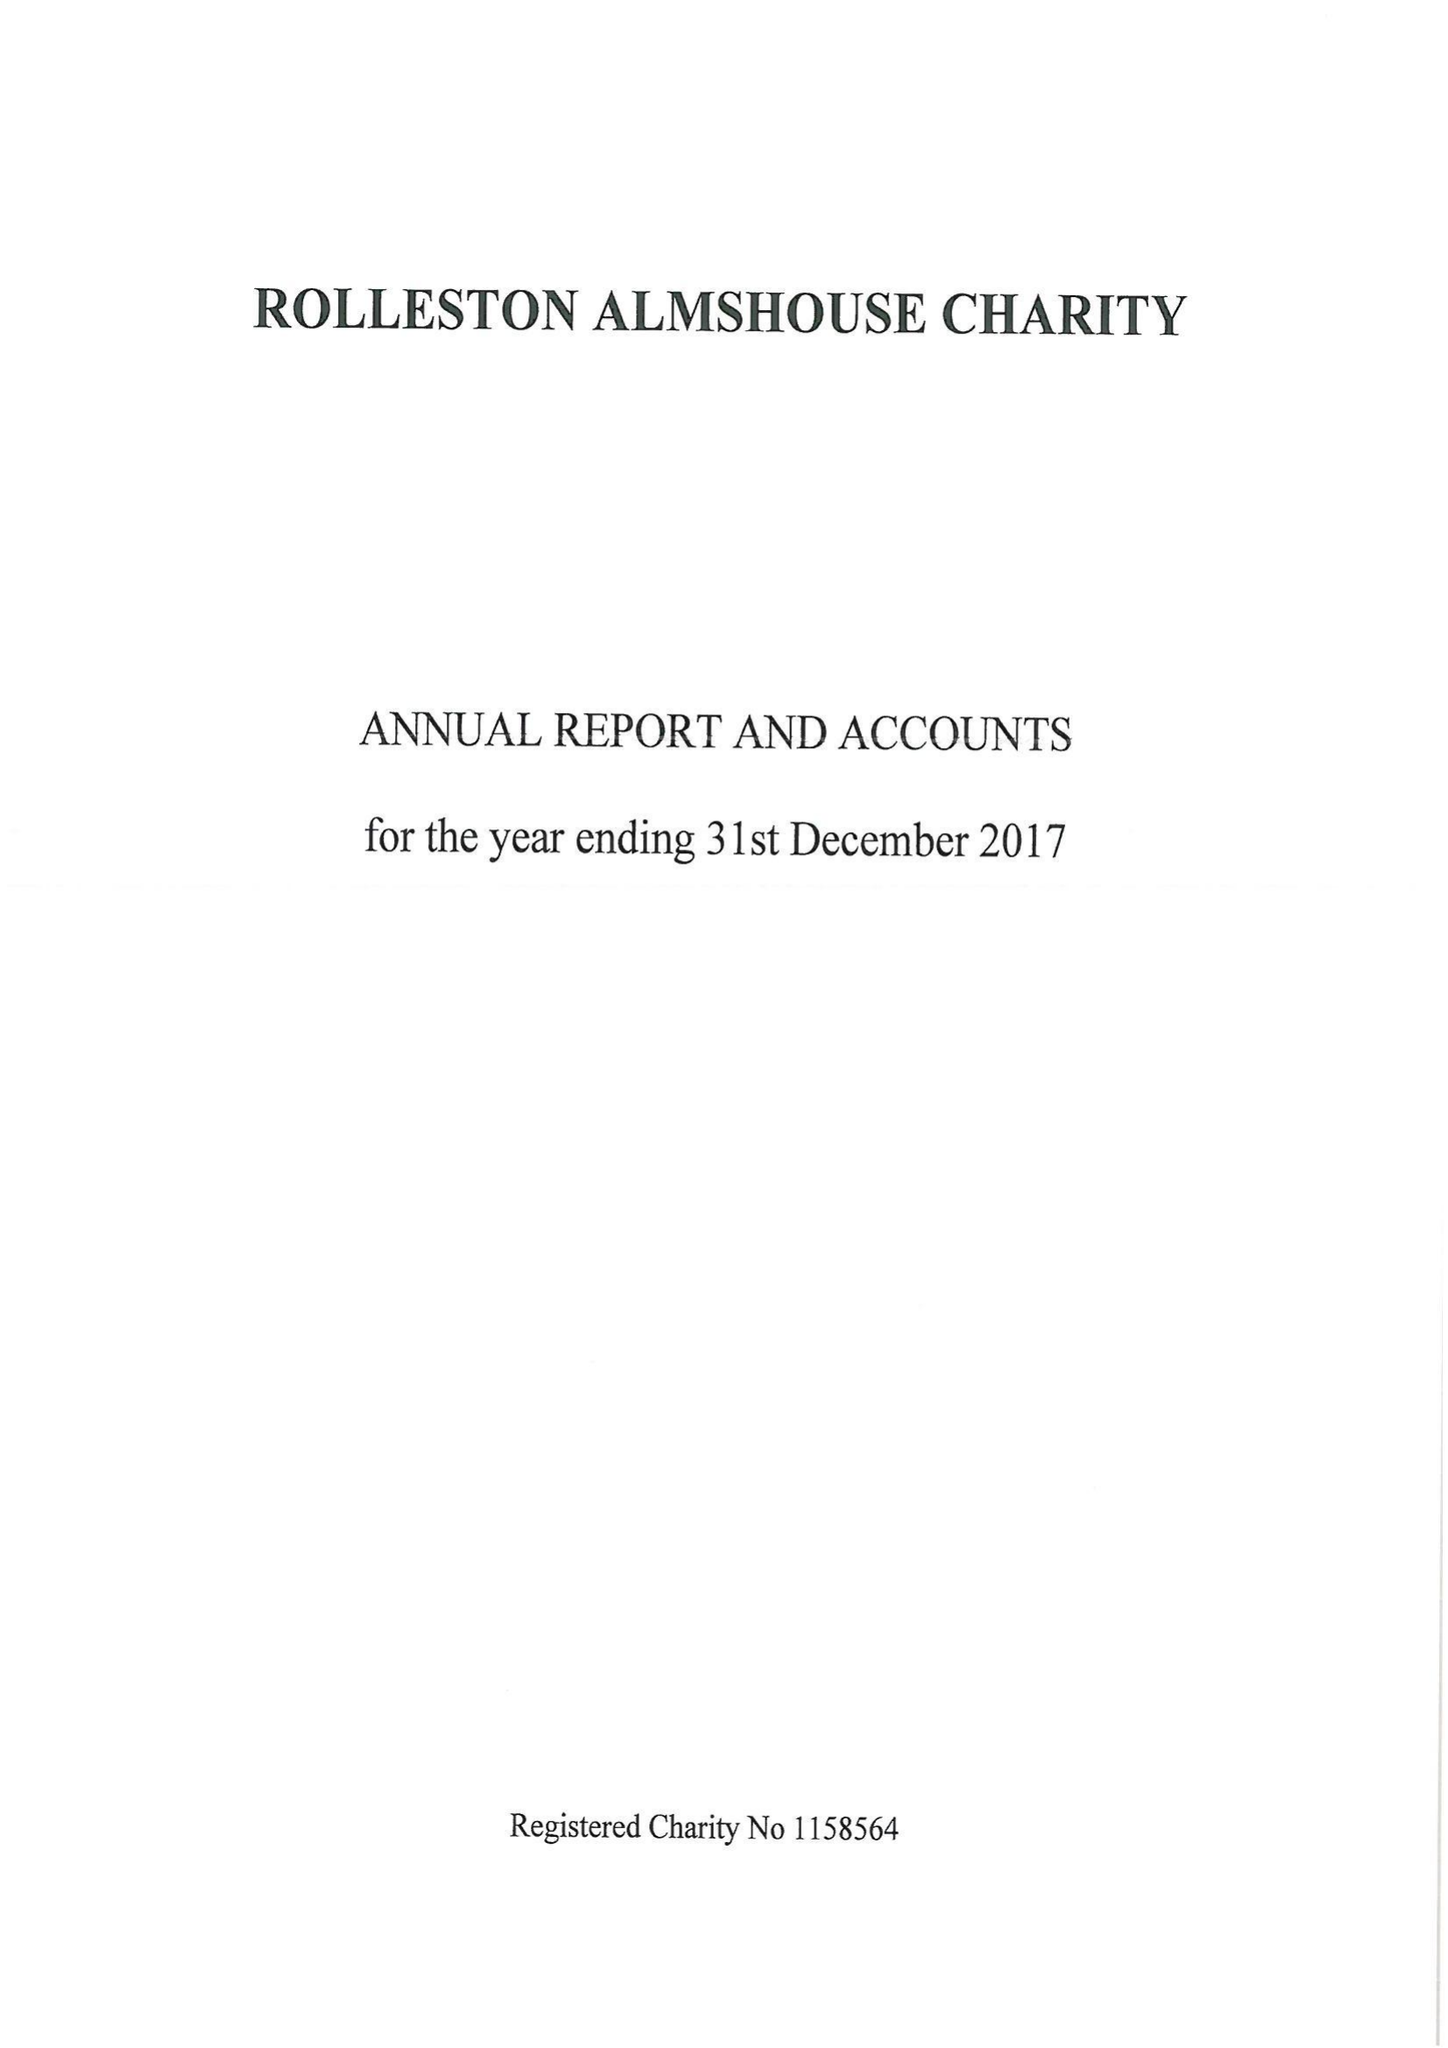What is the value for the address__street_line?
Answer the question using a single word or phrase. 148 HIGH STREET 